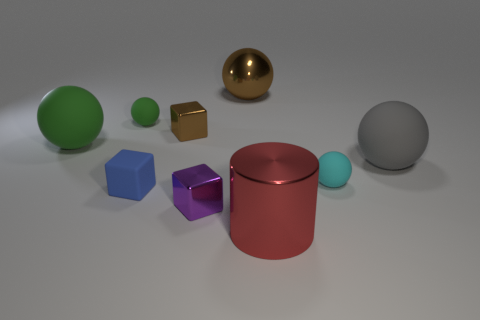Subtract 1 blue blocks. How many objects are left? 8 Subtract all cubes. How many objects are left? 6 Subtract 1 cylinders. How many cylinders are left? 0 Subtract all yellow cubes. Subtract all yellow spheres. How many cubes are left? 3 Subtract all cyan cylinders. How many yellow blocks are left? 0 Subtract all green spheres. Subtract all tiny brown shiny cubes. How many objects are left? 6 Add 5 gray rubber spheres. How many gray rubber spheres are left? 6 Add 2 spheres. How many spheres exist? 7 Add 1 tiny purple matte balls. How many objects exist? 10 Subtract all blue blocks. How many blocks are left? 2 